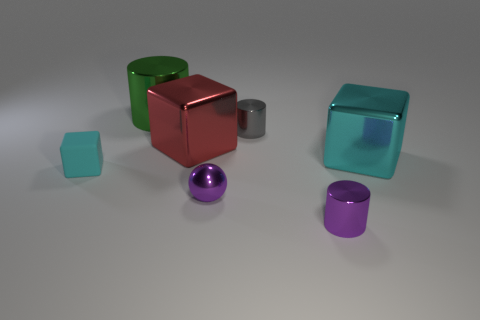The cylinder that is the same color as the ball is what size?
Ensure brevity in your answer.  Small. What number of cyan objects are either shiny things or cubes?
Your answer should be compact. 2. What is the material of the tiny cyan thing that is the same shape as the large red thing?
Your answer should be compact. Rubber. What shape is the thing to the left of the big green metal cylinder?
Ensure brevity in your answer.  Cube. Are there any other tiny purple cylinders that have the same material as the tiny purple cylinder?
Make the answer very short. No. Does the green object have the same size as the red cube?
Ensure brevity in your answer.  Yes. How many balls are either big cyan metallic things or purple things?
Your answer should be very brief. 1. What number of other small metal things are the same shape as the green shiny object?
Make the answer very short. 2. Are there more small metallic cylinders that are behind the big red metal cube than metallic blocks that are left of the gray object?
Make the answer very short. No. There is a tiny cylinder that is in front of the cyan matte thing; is its color the same as the sphere?
Your answer should be very brief. Yes. 